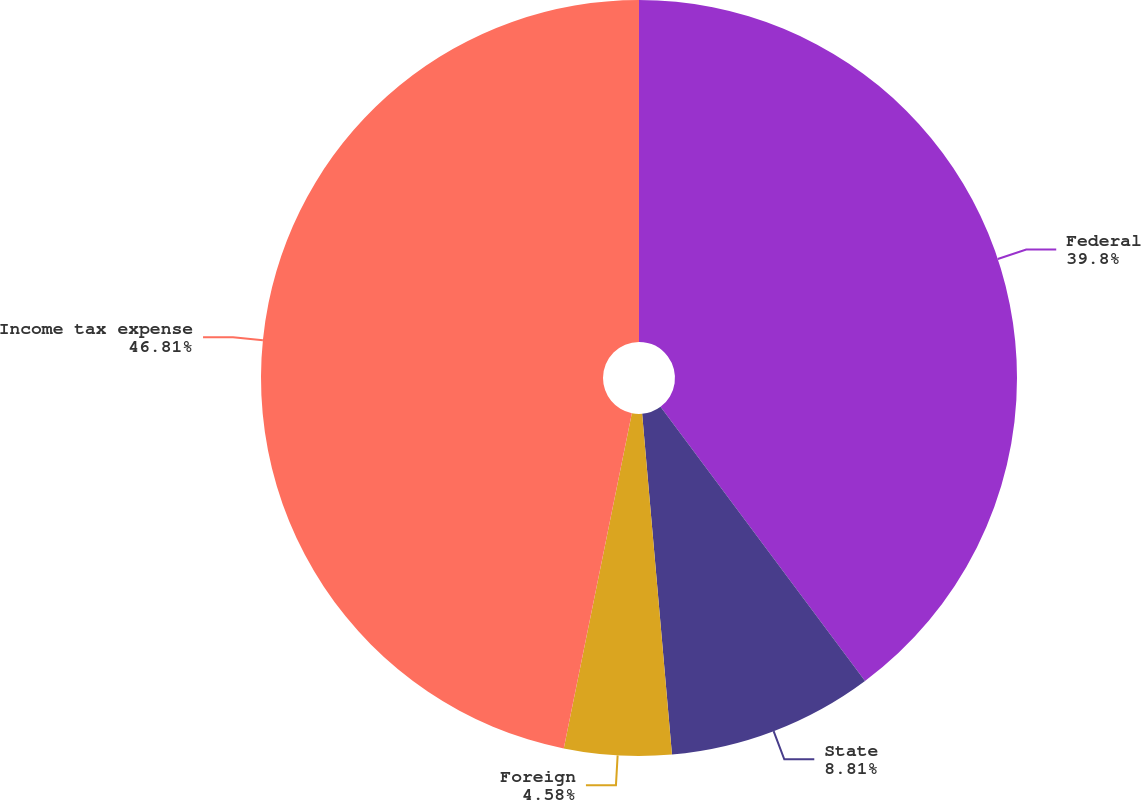Convert chart. <chart><loc_0><loc_0><loc_500><loc_500><pie_chart><fcel>Federal<fcel>State<fcel>Foreign<fcel>Income tax expense<nl><fcel>39.8%<fcel>8.81%<fcel>4.58%<fcel>46.81%<nl></chart> 